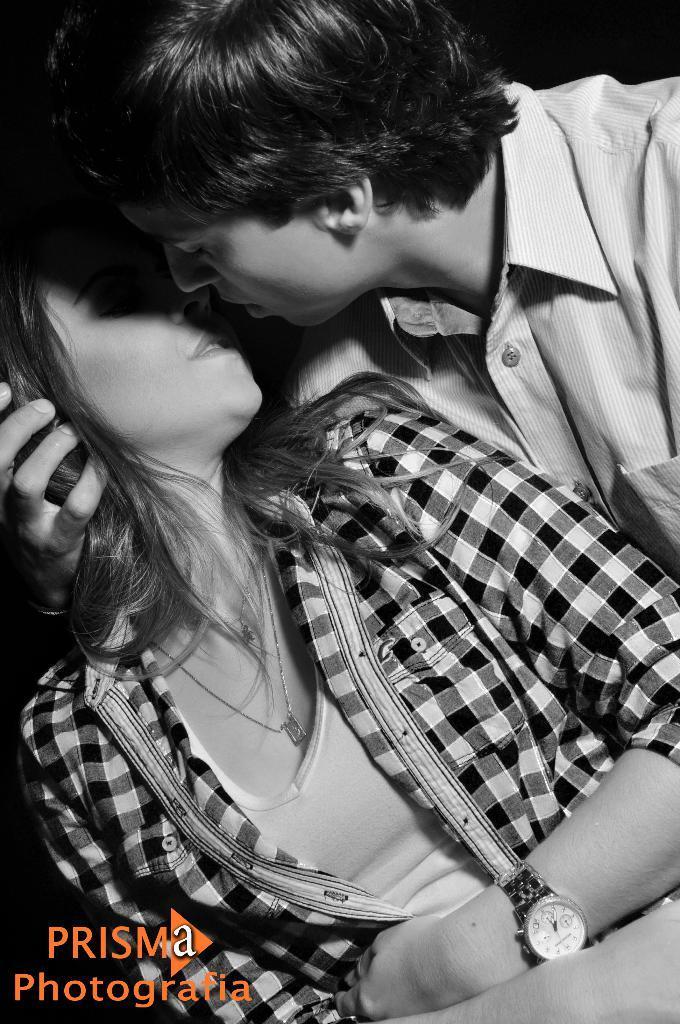Please provide a concise description of this image. This is a black and white image. There are a few people. We can also see some text on the bottom left corner. 